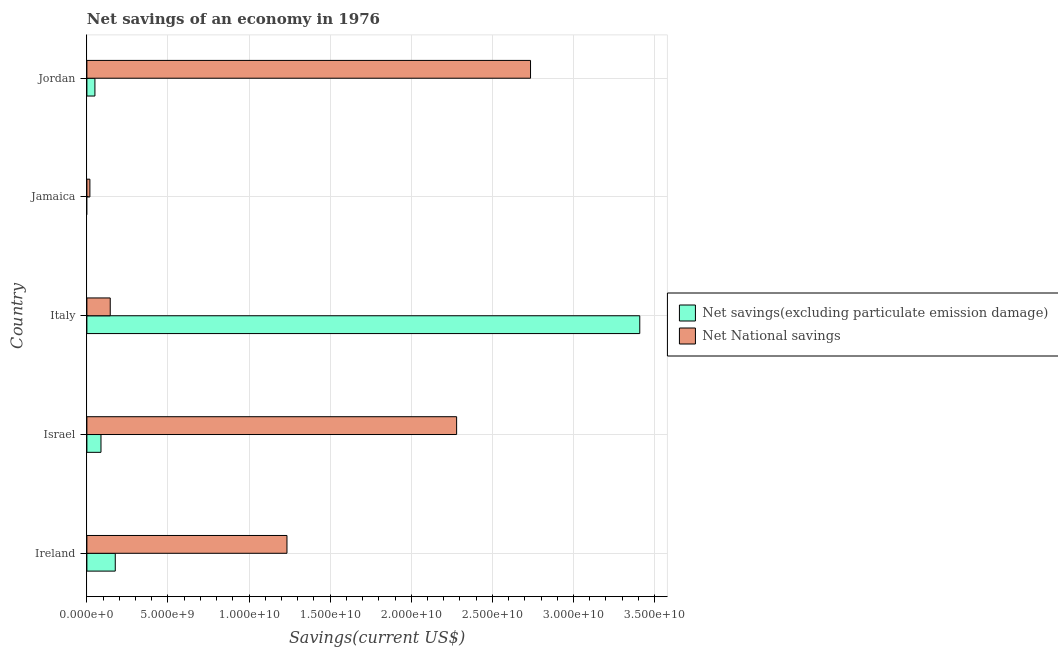Are the number of bars on each tick of the Y-axis equal?
Ensure brevity in your answer.  No. How many bars are there on the 4th tick from the top?
Make the answer very short. 2. What is the net savings(excluding particulate emission damage) in Israel?
Keep it short and to the point. 8.69e+08. Across all countries, what is the maximum net national savings?
Offer a very short reply. 2.74e+1. Across all countries, what is the minimum net national savings?
Offer a very short reply. 1.85e+08. In which country was the net savings(excluding particulate emission damage) maximum?
Offer a very short reply. Italy. What is the total net national savings in the graph?
Provide a succinct answer. 6.41e+1. What is the difference between the net national savings in Ireland and that in Jamaica?
Ensure brevity in your answer.  1.22e+1. What is the difference between the net savings(excluding particulate emission damage) in Israel and the net national savings in Ireland?
Ensure brevity in your answer.  -1.15e+1. What is the average net national savings per country?
Give a very brief answer. 1.28e+1. What is the difference between the net savings(excluding particulate emission damage) and net national savings in Israel?
Provide a succinct answer. -2.19e+1. In how many countries, is the net national savings greater than 18000000000 US$?
Provide a succinct answer. 2. What is the ratio of the net savings(excluding particulate emission damage) in Italy to that in Jordan?
Provide a short and direct response. 68.92. Is the net savings(excluding particulate emission damage) in Ireland less than that in Jordan?
Give a very brief answer. No. Is the difference between the net savings(excluding particulate emission damage) in Ireland and Italy greater than the difference between the net national savings in Ireland and Italy?
Provide a short and direct response. No. What is the difference between the highest and the second highest net national savings?
Provide a succinct answer. 4.56e+09. What is the difference between the highest and the lowest net national savings?
Give a very brief answer. 2.72e+1. In how many countries, is the net national savings greater than the average net national savings taken over all countries?
Your response must be concise. 2. How many bars are there?
Provide a short and direct response. 9. Are all the bars in the graph horizontal?
Offer a terse response. Yes. How many countries are there in the graph?
Your response must be concise. 5. Does the graph contain any zero values?
Your response must be concise. Yes. How many legend labels are there?
Your response must be concise. 2. How are the legend labels stacked?
Offer a terse response. Vertical. What is the title of the graph?
Provide a short and direct response. Net savings of an economy in 1976. What is the label or title of the X-axis?
Your answer should be compact. Savings(current US$). What is the Savings(current US$) of Net savings(excluding particulate emission damage) in Ireland?
Your answer should be very brief. 1.75e+09. What is the Savings(current US$) in Net National savings in Ireland?
Give a very brief answer. 1.23e+1. What is the Savings(current US$) in Net savings(excluding particulate emission damage) in Israel?
Keep it short and to the point. 8.69e+08. What is the Savings(current US$) in Net National savings in Israel?
Ensure brevity in your answer.  2.28e+1. What is the Savings(current US$) of Net savings(excluding particulate emission damage) in Italy?
Your answer should be compact. 3.41e+1. What is the Savings(current US$) of Net National savings in Italy?
Offer a very short reply. 1.44e+09. What is the Savings(current US$) of Net savings(excluding particulate emission damage) in Jamaica?
Your response must be concise. 0. What is the Savings(current US$) in Net National savings in Jamaica?
Your response must be concise. 1.85e+08. What is the Savings(current US$) of Net savings(excluding particulate emission damage) in Jordan?
Offer a very short reply. 4.95e+08. What is the Savings(current US$) of Net National savings in Jordan?
Your response must be concise. 2.74e+1. Across all countries, what is the maximum Savings(current US$) in Net savings(excluding particulate emission damage)?
Your response must be concise. 3.41e+1. Across all countries, what is the maximum Savings(current US$) of Net National savings?
Keep it short and to the point. 2.74e+1. Across all countries, what is the minimum Savings(current US$) in Net savings(excluding particulate emission damage)?
Keep it short and to the point. 0. Across all countries, what is the minimum Savings(current US$) of Net National savings?
Your answer should be very brief. 1.85e+08. What is the total Savings(current US$) of Net savings(excluding particulate emission damage) in the graph?
Your answer should be compact. 3.72e+1. What is the total Savings(current US$) in Net National savings in the graph?
Provide a short and direct response. 6.41e+1. What is the difference between the Savings(current US$) in Net savings(excluding particulate emission damage) in Ireland and that in Israel?
Offer a terse response. 8.80e+08. What is the difference between the Savings(current US$) in Net National savings in Ireland and that in Israel?
Provide a short and direct response. -1.05e+1. What is the difference between the Savings(current US$) of Net savings(excluding particulate emission damage) in Ireland and that in Italy?
Make the answer very short. -3.23e+1. What is the difference between the Savings(current US$) in Net National savings in Ireland and that in Italy?
Offer a very short reply. 1.09e+1. What is the difference between the Savings(current US$) of Net National savings in Ireland and that in Jamaica?
Offer a terse response. 1.22e+1. What is the difference between the Savings(current US$) of Net savings(excluding particulate emission damage) in Ireland and that in Jordan?
Give a very brief answer. 1.25e+09. What is the difference between the Savings(current US$) in Net National savings in Ireland and that in Jordan?
Provide a short and direct response. -1.50e+1. What is the difference between the Savings(current US$) in Net savings(excluding particulate emission damage) in Israel and that in Italy?
Make the answer very short. -3.32e+1. What is the difference between the Savings(current US$) of Net National savings in Israel and that in Italy?
Your response must be concise. 2.14e+1. What is the difference between the Savings(current US$) of Net National savings in Israel and that in Jamaica?
Provide a succinct answer. 2.26e+1. What is the difference between the Savings(current US$) of Net savings(excluding particulate emission damage) in Israel and that in Jordan?
Offer a terse response. 3.74e+08. What is the difference between the Savings(current US$) of Net National savings in Israel and that in Jordan?
Your answer should be compact. -4.56e+09. What is the difference between the Savings(current US$) of Net National savings in Italy and that in Jamaica?
Provide a succinct answer. 1.25e+09. What is the difference between the Savings(current US$) of Net savings(excluding particulate emission damage) in Italy and that in Jordan?
Ensure brevity in your answer.  3.36e+1. What is the difference between the Savings(current US$) in Net National savings in Italy and that in Jordan?
Make the answer very short. -2.59e+1. What is the difference between the Savings(current US$) of Net National savings in Jamaica and that in Jordan?
Make the answer very short. -2.72e+1. What is the difference between the Savings(current US$) in Net savings(excluding particulate emission damage) in Ireland and the Savings(current US$) in Net National savings in Israel?
Make the answer very short. -2.10e+1. What is the difference between the Savings(current US$) of Net savings(excluding particulate emission damage) in Ireland and the Savings(current US$) of Net National savings in Italy?
Provide a succinct answer. 3.11e+08. What is the difference between the Savings(current US$) in Net savings(excluding particulate emission damage) in Ireland and the Savings(current US$) in Net National savings in Jamaica?
Offer a very short reply. 1.56e+09. What is the difference between the Savings(current US$) in Net savings(excluding particulate emission damage) in Ireland and the Savings(current US$) in Net National savings in Jordan?
Make the answer very short. -2.56e+1. What is the difference between the Savings(current US$) of Net savings(excluding particulate emission damage) in Israel and the Savings(current US$) of Net National savings in Italy?
Your response must be concise. -5.70e+08. What is the difference between the Savings(current US$) in Net savings(excluding particulate emission damage) in Israel and the Savings(current US$) in Net National savings in Jamaica?
Make the answer very short. 6.84e+08. What is the difference between the Savings(current US$) of Net savings(excluding particulate emission damage) in Israel and the Savings(current US$) of Net National savings in Jordan?
Ensure brevity in your answer.  -2.65e+1. What is the difference between the Savings(current US$) in Net savings(excluding particulate emission damage) in Italy and the Savings(current US$) in Net National savings in Jamaica?
Offer a very short reply. 3.39e+1. What is the difference between the Savings(current US$) of Net savings(excluding particulate emission damage) in Italy and the Savings(current US$) of Net National savings in Jordan?
Offer a very short reply. 6.74e+09. What is the average Savings(current US$) in Net savings(excluding particulate emission damage) per country?
Ensure brevity in your answer.  7.44e+09. What is the average Savings(current US$) of Net National savings per country?
Make the answer very short. 1.28e+1. What is the difference between the Savings(current US$) of Net savings(excluding particulate emission damage) and Savings(current US$) of Net National savings in Ireland?
Ensure brevity in your answer.  -1.06e+1. What is the difference between the Savings(current US$) in Net savings(excluding particulate emission damage) and Savings(current US$) in Net National savings in Israel?
Offer a terse response. -2.19e+1. What is the difference between the Savings(current US$) in Net savings(excluding particulate emission damage) and Savings(current US$) in Net National savings in Italy?
Ensure brevity in your answer.  3.26e+1. What is the difference between the Savings(current US$) in Net savings(excluding particulate emission damage) and Savings(current US$) in Net National savings in Jordan?
Give a very brief answer. -2.69e+1. What is the ratio of the Savings(current US$) in Net savings(excluding particulate emission damage) in Ireland to that in Israel?
Provide a short and direct response. 2.01. What is the ratio of the Savings(current US$) in Net National savings in Ireland to that in Israel?
Provide a short and direct response. 0.54. What is the ratio of the Savings(current US$) of Net savings(excluding particulate emission damage) in Ireland to that in Italy?
Your answer should be very brief. 0.05. What is the ratio of the Savings(current US$) in Net National savings in Ireland to that in Italy?
Your response must be concise. 8.57. What is the ratio of the Savings(current US$) in Net National savings in Ireland to that in Jamaica?
Keep it short and to the point. 66.7. What is the ratio of the Savings(current US$) in Net savings(excluding particulate emission damage) in Ireland to that in Jordan?
Ensure brevity in your answer.  3.54. What is the ratio of the Savings(current US$) in Net National savings in Ireland to that in Jordan?
Give a very brief answer. 0.45. What is the ratio of the Savings(current US$) of Net savings(excluding particulate emission damage) in Israel to that in Italy?
Offer a terse response. 0.03. What is the ratio of the Savings(current US$) in Net National savings in Israel to that in Italy?
Provide a succinct answer. 15.84. What is the ratio of the Savings(current US$) in Net National savings in Israel to that in Jamaica?
Provide a short and direct response. 123.26. What is the ratio of the Savings(current US$) in Net savings(excluding particulate emission damage) in Israel to that in Jordan?
Provide a short and direct response. 1.76. What is the ratio of the Savings(current US$) of Net National savings in Israel to that in Jordan?
Provide a short and direct response. 0.83. What is the ratio of the Savings(current US$) in Net National savings in Italy to that in Jamaica?
Provide a short and direct response. 7.78. What is the ratio of the Savings(current US$) of Net savings(excluding particulate emission damage) in Italy to that in Jordan?
Ensure brevity in your answer.  68.91. What is the ratio of the Savings(current US$) in Net National savings in Italy to that in Jordan?
Offer a terse response. 0.05. What is the ratio of the Savings(current US$) of Net National savings in Jamaica to that in Jordan?
Your response must be concise. 0.01. What is the difference between the highest and the second highest Savings(current US$) of Net savings(excluding particulate emission damage)?
Provide a succinct answer. 3.23e+1. What is the difference between the highest and the second highest Savings(current US$) of Net National savings?
Offer a terse response. 4.56e+09. What is the difference between the highest and the lowest Savings(current US$) in Net savings(excluding particulate emission damage)?
Your answer should be very brief. 3.41e+1. What is the difference between the highest and the lowest Savings(current US$) of Net National savings?
Ensure brevity in your answer.  2.72e+1. 